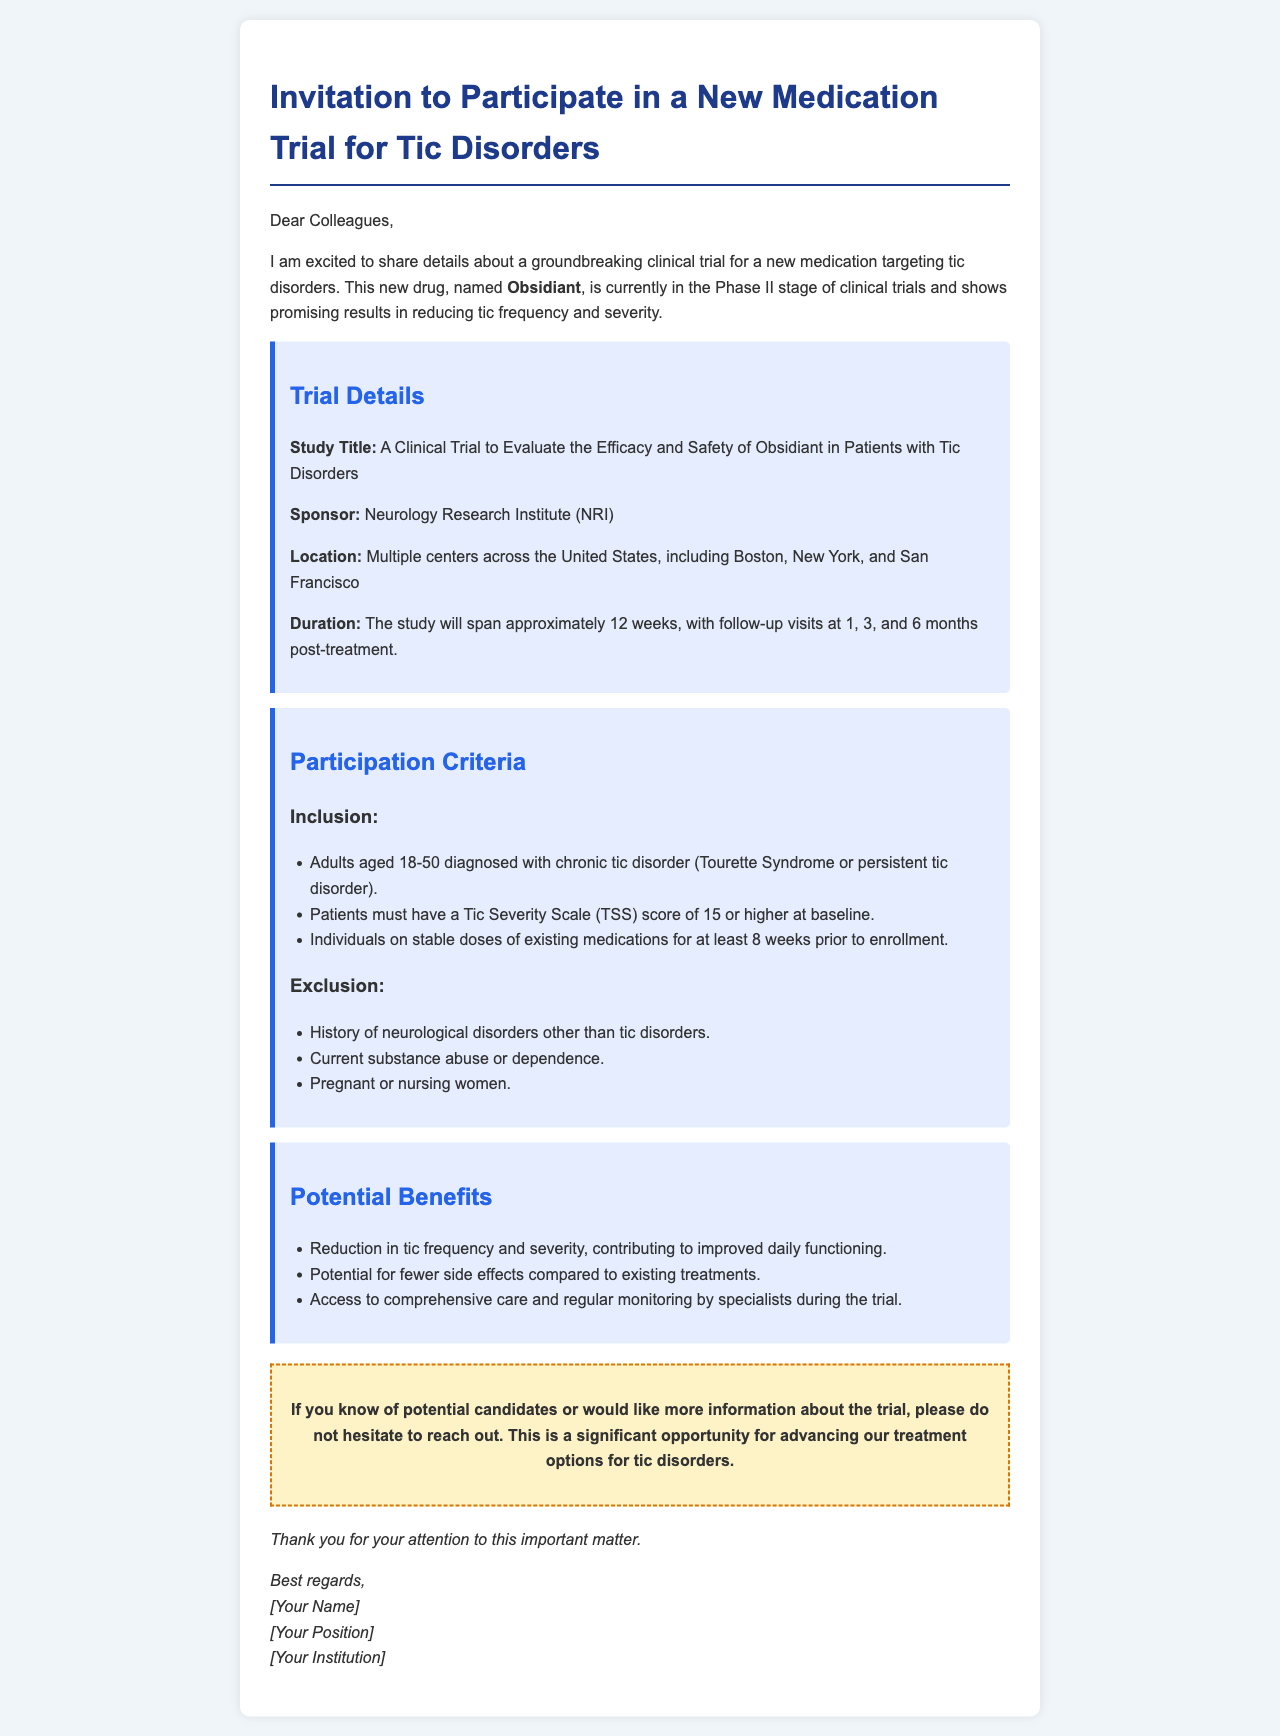What is the name of the new medication? The document explicitly states the name of the new medication as Obsidiant.
Answer: Obsidiant What is the age range for participants? The inclusion criteria specify that participants must be adults aged 18-50.
Answer: 18-50 How long is the duration of the study? The document mentions that the study will span approximately 12 weeks.
Answer: 12 weeks What is the required Tic Severity Scale score for eligibility? The inclusion criteria indicate the necessary Tic Severity Scale score must be 15 or higher at baseline.
Answer: 15 Who is sponsoring the trial? The document specifies that the Neurology Research Institute (NRI) is sponsoring the trial.
Answer: Neurology Research Institute (NRI) Which cities will the trial be conducted in? The document lists multiple centers in cities including Boston, New York, and San Francisco.
Answer: Boston, New York, San Francisco What are the potential benefits of participation? The document outlines that benefits include reduction in tic frequency, potential for fewer side effects, and access to care.
Answer: Reduction in tic frequency and severity, potential for fewer side effects, access to comprehensive care What should you do if you know potential candidates? The call-to-action section suggests reaching out for more information if you know potential candidates.
Answer: Reach out for more information What is the follow-up schedule after treatment? The document states there will be follow-up visits at 1, 3, and 6 months post-treatment.
Answer: 1, 3, and 6 months 